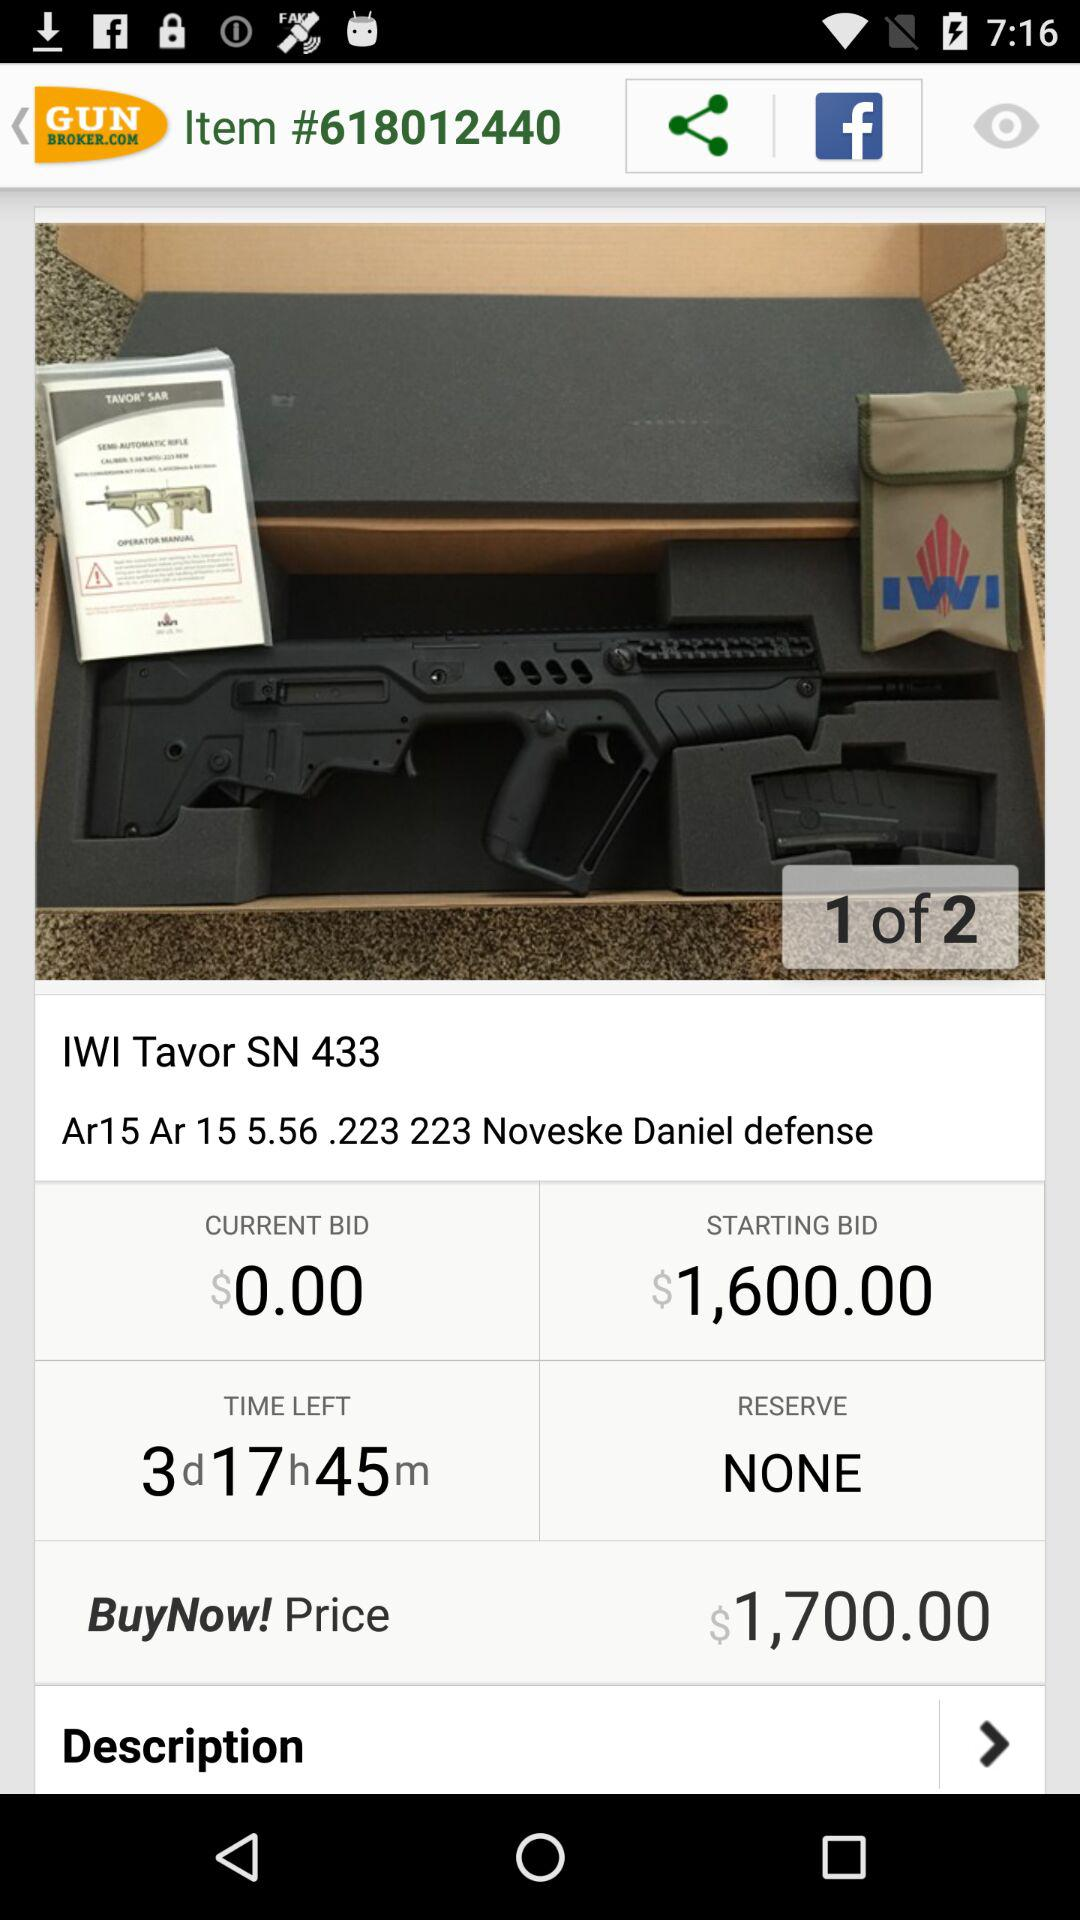What is the starting bid? The starting bid is $1,600. 